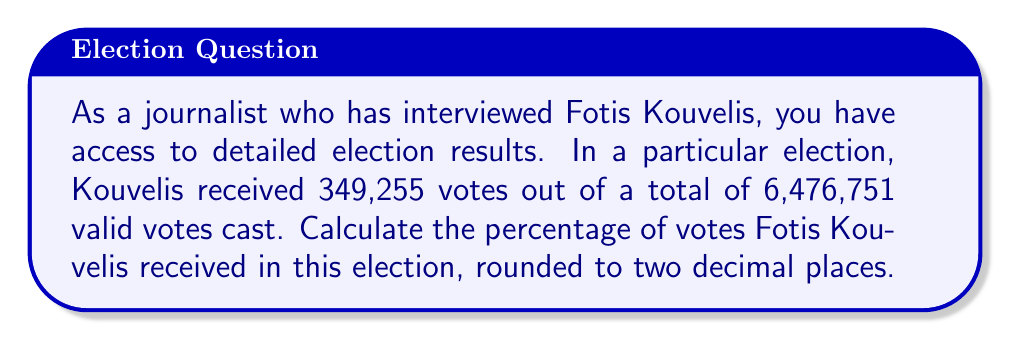Solve this math problem. To calculate the percentage of votes Fotis Kouvelis received, we need to divide the number of votes he received by the total number of valid votes cast, and then multiply by 100 to convert to a percentage.

Let's define:
$v$ = number of votes Kouvelis received = 349,255
$t$ = total number of valid votes cast = 6,476,751

The formula to calculate the percentage is:

$$ \text{Percentage} = \frac{v}{t} \times 100 $$

Substituting the values:

$$ \text{Percentage} = \frac{349,255}{6,476,751} \times 100 $$

Using a calculator or computer:

$$ \text{Percentage} = 0.0539250864... \times 100 = 5.39250864... $$

Rounding to two decimal places:

$$ \text{Percentage} \approx 5.39\% $$
Answer: 5.39% 